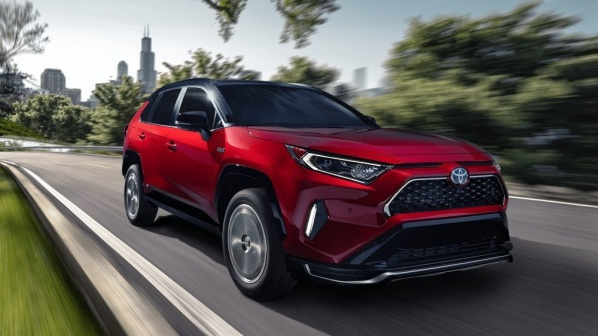What kind of journey could the driver of this car be on? The driver of this red Toyota RAV4 could be on a weekend getaway, perhaps heading out of the city for a relaxing escape into nature. The journey could involve driving through scenic routes, passing by beautiful landscapes, and enjoying the versatility and comfort of the SUV. The car provides ample space for luggage, making it perfect for long trips. The robust design and advanced features ensure a safe and enjoyable drive, whether in the city or on winding country roads. 